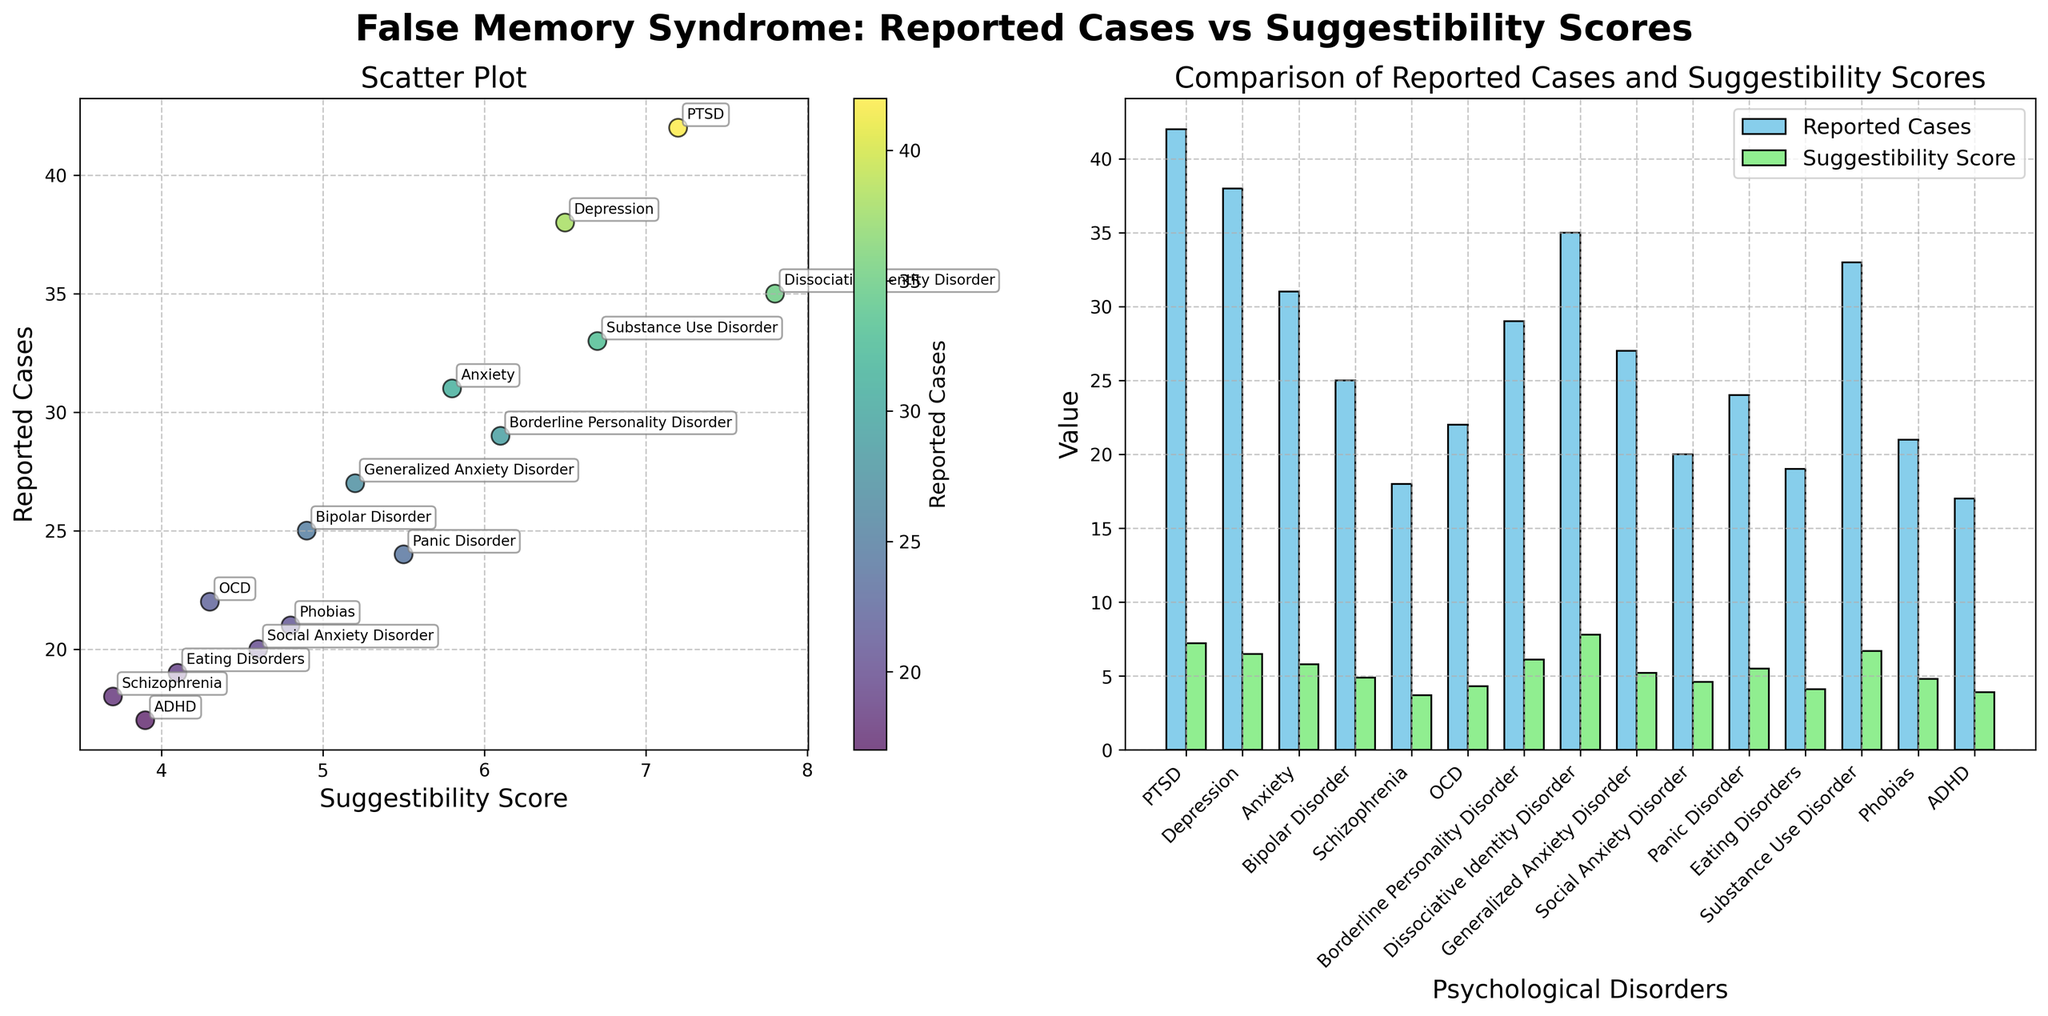What's the main title of the figure? The main title of a figure is typically located at the top and summarizes what the figure is about. In this case, it is bold and concise, indicating the principal analysis.
Answer: False Memory Syndrome: Reported Cases vs Suggestibility Scores What are the axes labels on the scatter plot? Axes labels provide an understanding of what the x and y axes represent. In this scatter plot, the x-axis represents the Suggestibility Scores, and the y-axis represents the Reported Cases.
Answer: X-axis: Suggestibility Score, Y-axis: Reported Cases How many psychological disorders are visualized in the scatter plot? Each data point in the scatter plot represents a psychological disorder. Counting all labeled points will give the total number of disorders.
Answer: 15 Which psychological disorder has the highest suggestibility score? By looking at the x-axis values, the disorder located furthest to the right has the highest suggestibility score. According to the annotations, that is Dissociative Identity Disorder.
Answer: Dissociative Identity Disorder Which psychological disorder has the highest number of reported cases? The disorder with the highest y-axis value has the most reported cases. According to the annotations, that is PTSD.
Answer: PTSD What is the suggestibility score for Borderline Personality Disorder? Locate the data point labeled Borderline Personality Disorder on the scatter plot and check its x-axis value.
Answer: 6.1 How do the reported cases of PTSD compare to Schizophrenia? Look at the y-axis values of PTSD and Schizophrenia data points. PTSD has a much higher y-value compared to Schizophrenia.
Answer: PTSD has more reported cases than Schizophrenia What is the trend in the relationship between suggestibility scores and reported cases seen in the scatter plot? Observe the overall pattern of how points are distributed. If higher suggestibility scores tend to correlate with higher reported cases, there's a positive trend.
Answer: Positive correlation Between Depression and Substance Use Disorder, which has a higher suggestibility score and by how much? Compare the x-axis values for both disorders. Depression has a suggestibility score of 6.5, while Substance Use Disorder has 6.7. The difference can be calculated as 6.7 - 6.5.
Answer: Substance Use Disorder by 0.2 What can be deduced about the relationship between psychological disorders and false memory syndrome from this figure? While examining both plots, any notable increase in reported cases with increasing suggestibility scores suggests a potential relationship where disorders with higher suggestibility tend to have more reported false memory syndrome cases. This insight requires deeper analysis beyond visual trends to establish causality.
Answer: Higher suggestibility often correlates with more reported cases of false memory syndrome 